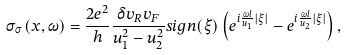Convert formula to latex. <formula><loc_0><loc_0><loc_500><loc_500>\sigma _ { \sigma } ( x , \omega ) = \frac { 2 e ^ { 2 } } { h } \frac { \delta v _ { R } v _ { F } } { u _ { 1 } ^ { 2 } - u _ { 2 } ^ { 2 } } s i g n ( \xi ) \left ( e ^ { i \frac { \omega l } { u _ { 1 } } | \xi | } - e ^ { i \frac { \omega l } { u _ { 2 } } | \xi | } \right ) ,</formula> 